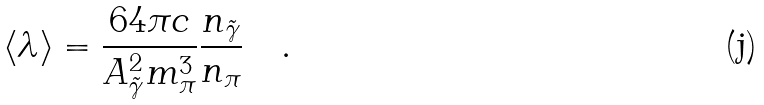Convert formula to latex. <formula><loc_0><loc_0><loc_500><loc_500>\langle \lambda \rangle = \frac { 6 4 \pi c } { A _ { \tilde { \gamma } } ^ { 2 } m _ { \pi } ^ { 3 } } \frac { n _ { \tilde { \gamma } } } { n _ { \pi } } \quad .</formula> 